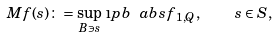<formula> <loc_0><loc_0><loc_500><loc_500>M f ( s ) \colon = \sup _ { B \ni s } \, \i p b { \ a b s { f } } _ { 1 , Q } , \quad s \in S ,</formula> 